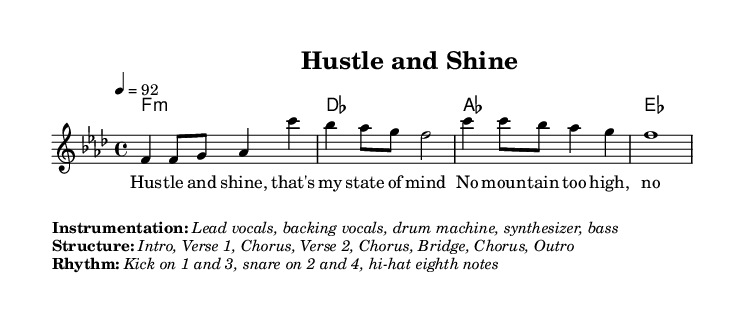What is the key signature of this music? The key signature is F minor, indicated by the presence of four flats (B♭, E♭, A♭, and D♭). This is derived from the beginning of the melody where the key is established.
Answer: F minor What is the time signature of this music? The time signature is 4/4, which means there are four beats in each measure and the quarter note receives one beat. This can be identified from the time signature indication at the beginning of the piece.
Answer: 4/4 What is the tempo marking of the piece? The tempo marking is 92 beats per minute, indicated by the term "4 = 92" following the tempo marking. This shows how fast the piece should be played.
Answer: 92 How many bars are there in the chorus? The chorus consists of four bars, indicated by the four measures of melody provided in the sheet music written under the selected structure of the song.
Answer: 4 What instrumentation is mentioned for the track? The instrumentation includes lead vocals, backing vocals, drum machine, synthesizer, and bass. This information is provided in the markup section that details the performance setup.
Answer: Lead vocals, backing vocals, drum machine, synthesizer, bass In which part of the song does the line "Hustle and shine, that's my state of mind" appear? This line appears in the verse section, as it is specifically noted in the lyrics section where it describes the theme of perseverance central to the song's message.
Answer: Verse 